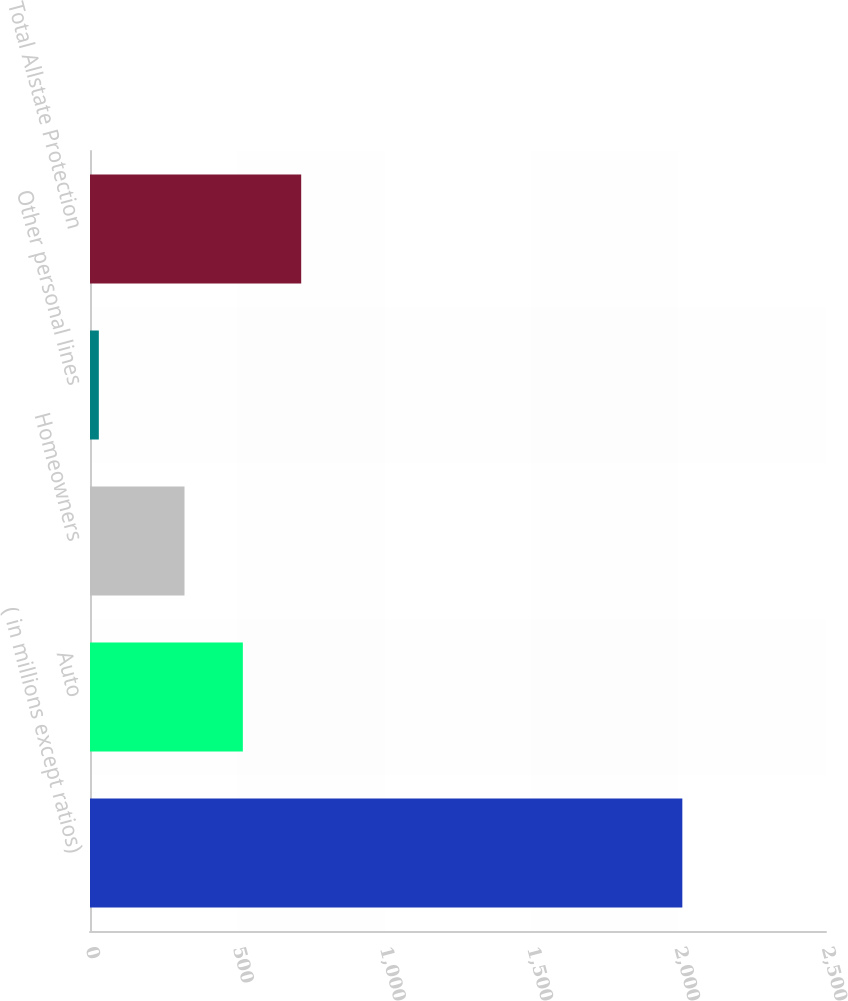Convert chart. <chart><loc_0><loc_0><loc_500><loc_500><bar_chart><fcel>( in millions except ratios)<fcel>Auto<fcel>Homeowners<fcel>Other personal lines<fcel>Total Allstate Protection<nl><fcel>2012<fcel>519.2<fcel>321<fcel>30<fcel>717.4<nl></chart> 